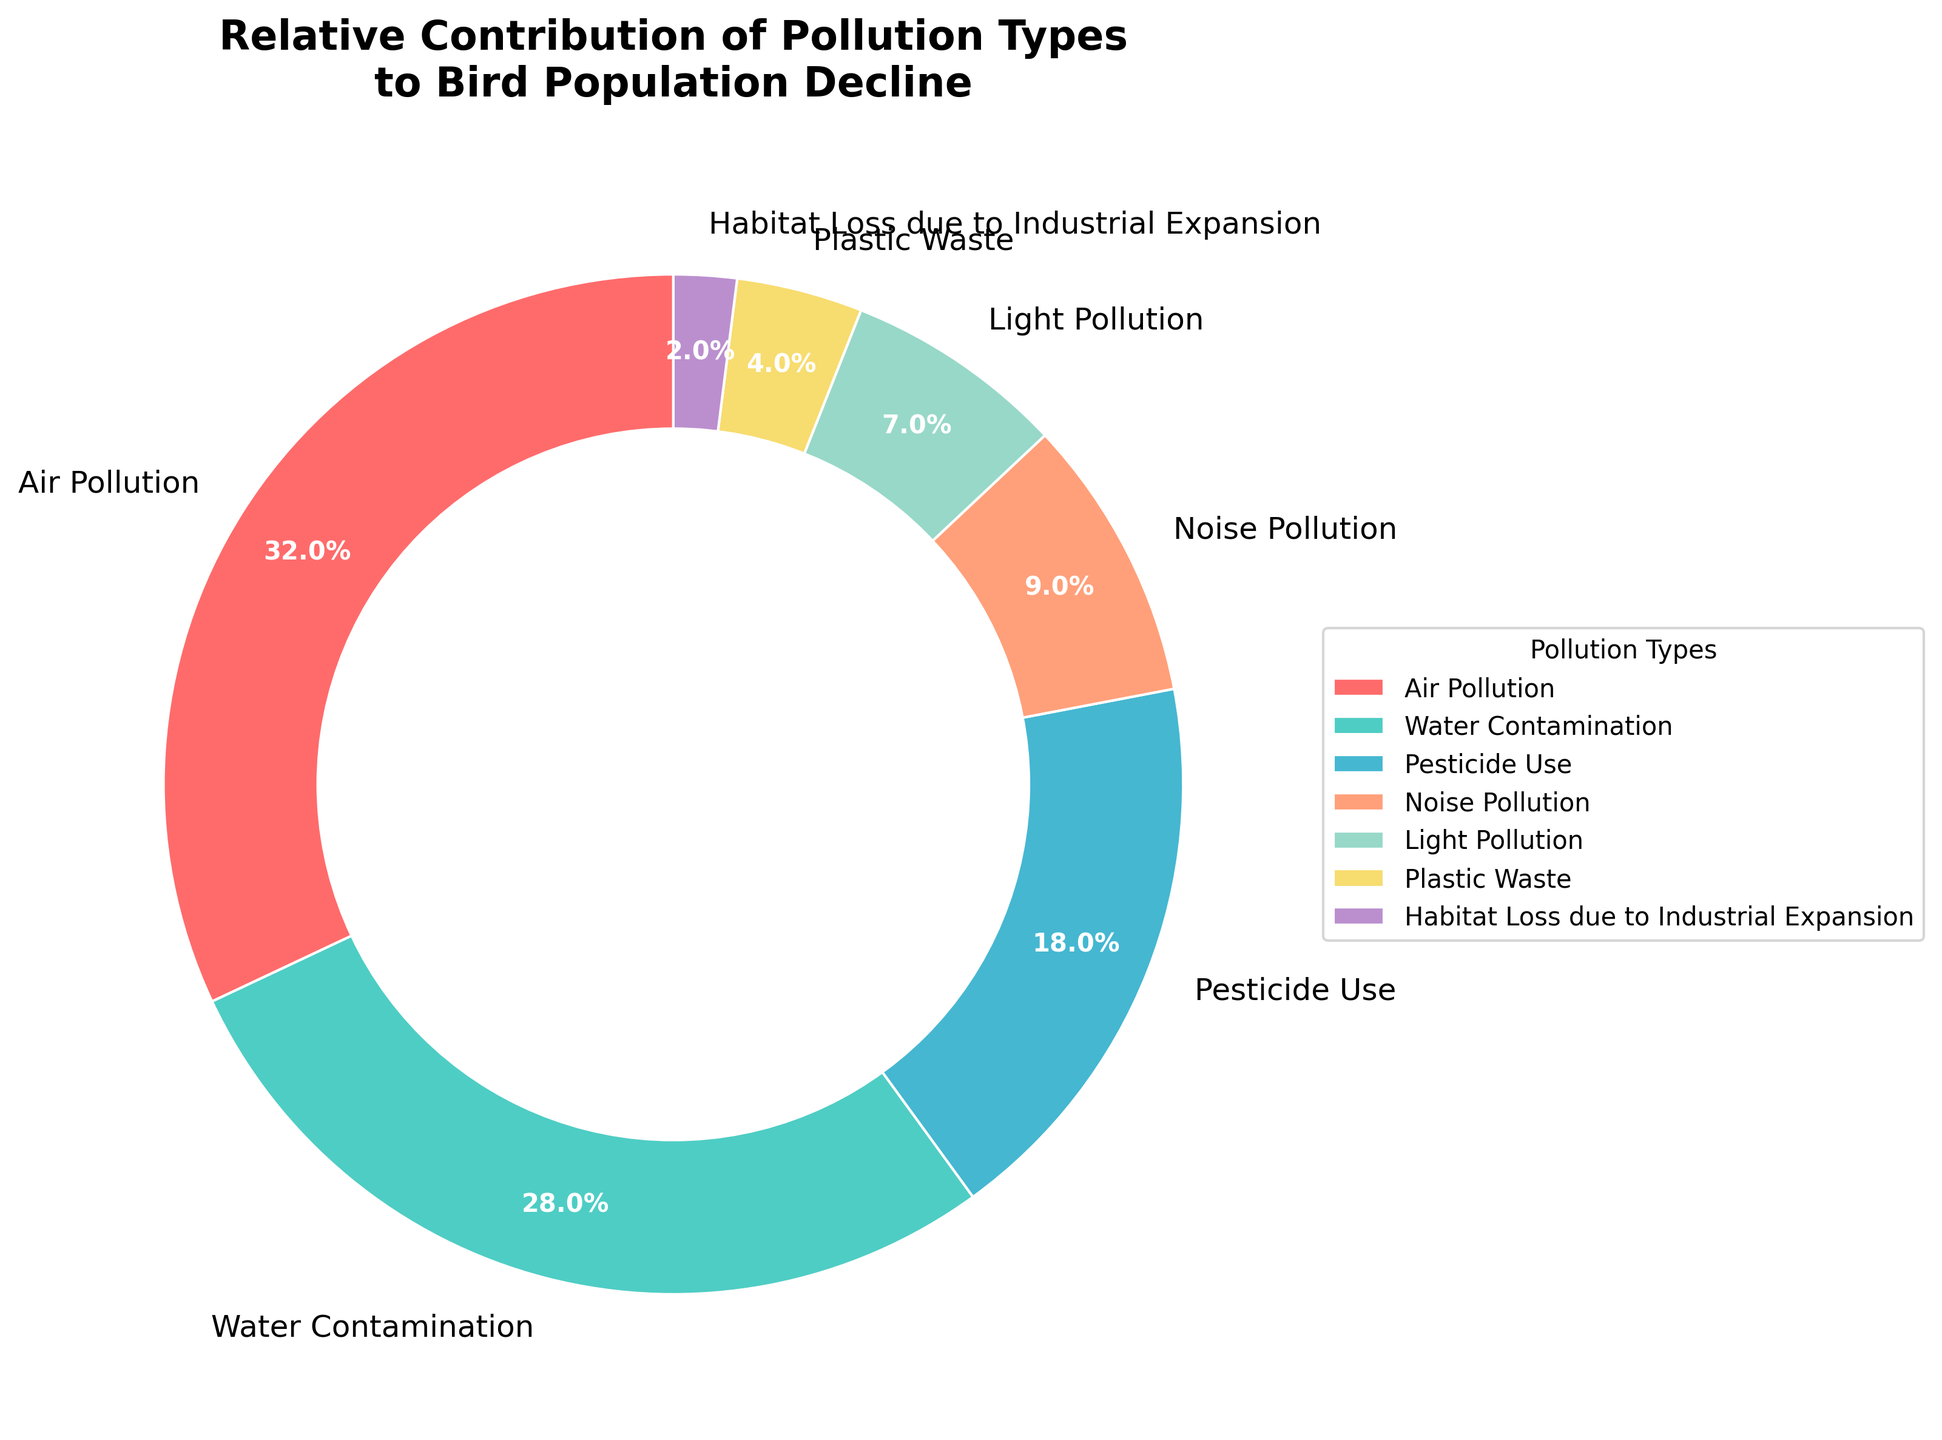Which pollution type contributes the most to bird population decline? The figure shows a pie chart with various pollution types and their percentage contributions. By looking at the largest wedge, it's apparent that the pollution type with the highest percentage is Air Pollution at 32%.
Answer: Air Pollution What is the combined percentage contribution of Water Contamination and Pesticide Use? First, locate the percentages for Water Contamination (28%) and Pesticide Use (18%) on the pie chart. Then add these two values together: 28% + 18% = 46%.
Answer: 46% Which pollution type has the least impact on bird population decline? The pie chart displays the percentage contributions of different pollution types. The smallest wedge, representing the lowest percentage, belongs to Habitat Loss due to Industrial Expansion at 2%.
Answer: Habitat Loss due to Industrial Expansion How does the contribution of Noise Pollution compare to that of Light Pollution? Locate the slices for Noise Pollution (9%) and Light Pollution (7%). By comparing the percentages, see that Noise Pollution has a higher contribution than Light Pollution.
Answer: Noise Pollution is higher What percentage of the pollution types contribute less than 10% each to the bird population decline? Identify the wedges that each have a percentage less than 10%: Noise Pollution (9%), Light Pollution (7%), Plastic Waste (4%), and Habitat Loss due to Industrial Expansion (2%). Then sum these percentages: 9% + 7% + 4% + 2% = 22%.
Answer: 22% What is the difference in percentage contribution between Air Pollution and Plastic Waste? Find the percentages for Air Pollution (32%) and Plastic Waste (4%) and then subtract the smaller percentage from the larger one: 32% - 4% = 28%.
Answer: 28% If we combine the contributions of the two smallest pollution types, what does their total percentage represent relative to the largest pollution type? Identify the two smallest pollution types: Habitat Loss due to Industrial Expansion (2%) and Plastic Waste (4%). Add their percentages: 2% + 4% = 6%. Then compare to the largest type (Air Pollution at 32%) by dividing the summed percentage by the largest percentage and multiplying by 100: (6% / 32%) * 100 = 18.75%.
Answer: 18.75% Are there more pollution types contributing less than 15% each or more than 15% each to the bird population decline? Count the number of pollution types contributing less than 15%: Noise Pollution (9%), Light Pollution (7%), Plastic Waste (4%), and Habitat Loss due to Industrial Expansion (2%) = 4 types. Count the number of pollution types contributing more than 15%: Air Pollution (32%), Water Contamination (28%), and Pesticide Use (18%) = 3 types.
Answer: Less than 15% 